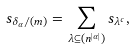<formula> <loc_0><loc_0><loc_500><loc_500>s _ { \delta _ { \alpha } / ( m ) } = \sum _ { \lambda \subseteq ( n ^ { | \alpha | } ) } s _ { \lambda ^ { c } } ,</formula> 